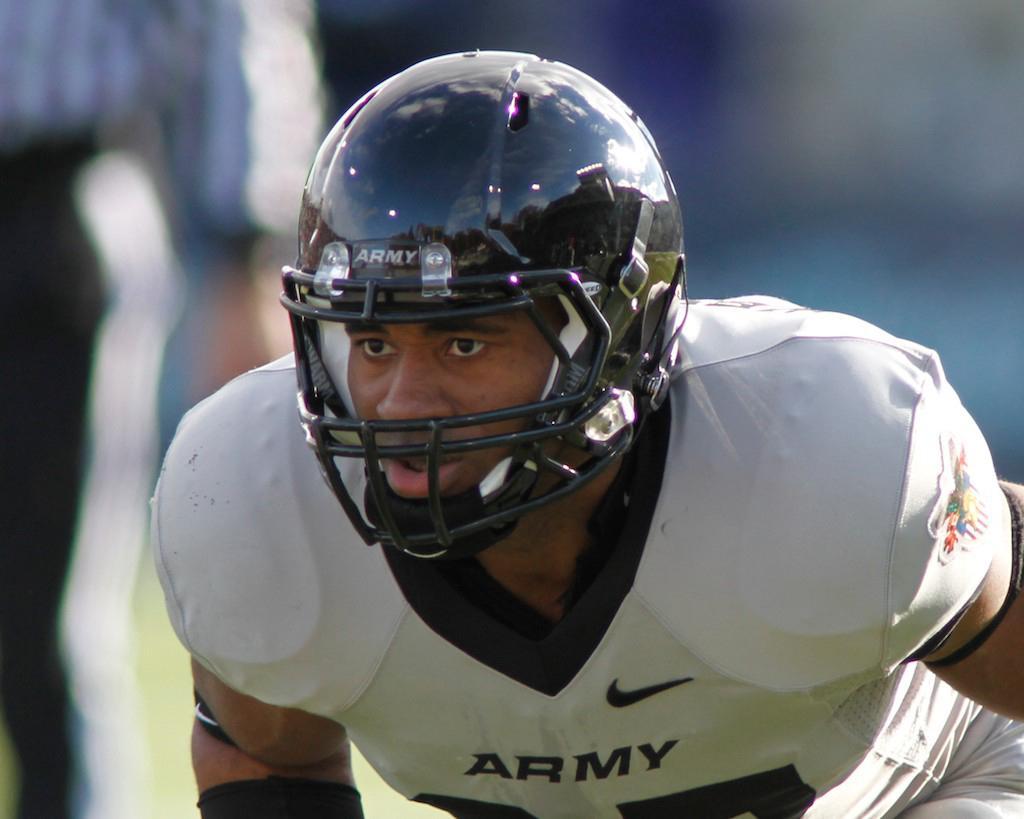Can you describe this image briefly? In this image I can see a man is wearing a helmet and white color clothes. The background of the image is blurred. 